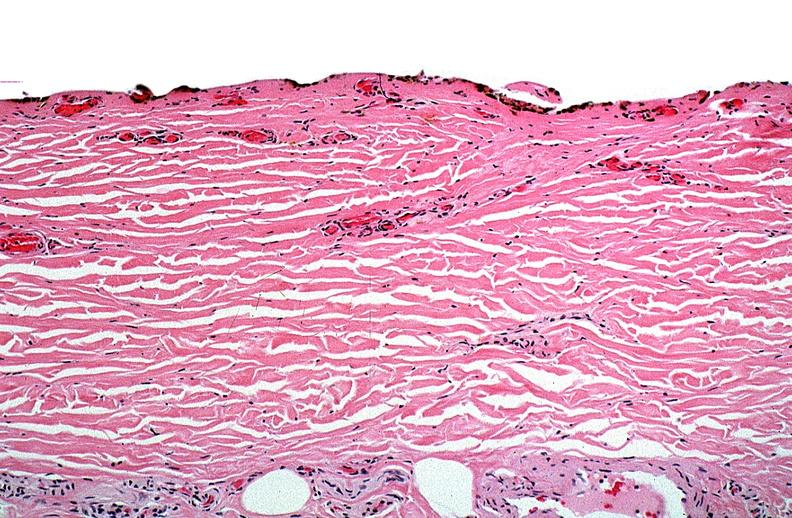does this image show thermal burned skin?
Answer the question using a single word or phrase. Yes 